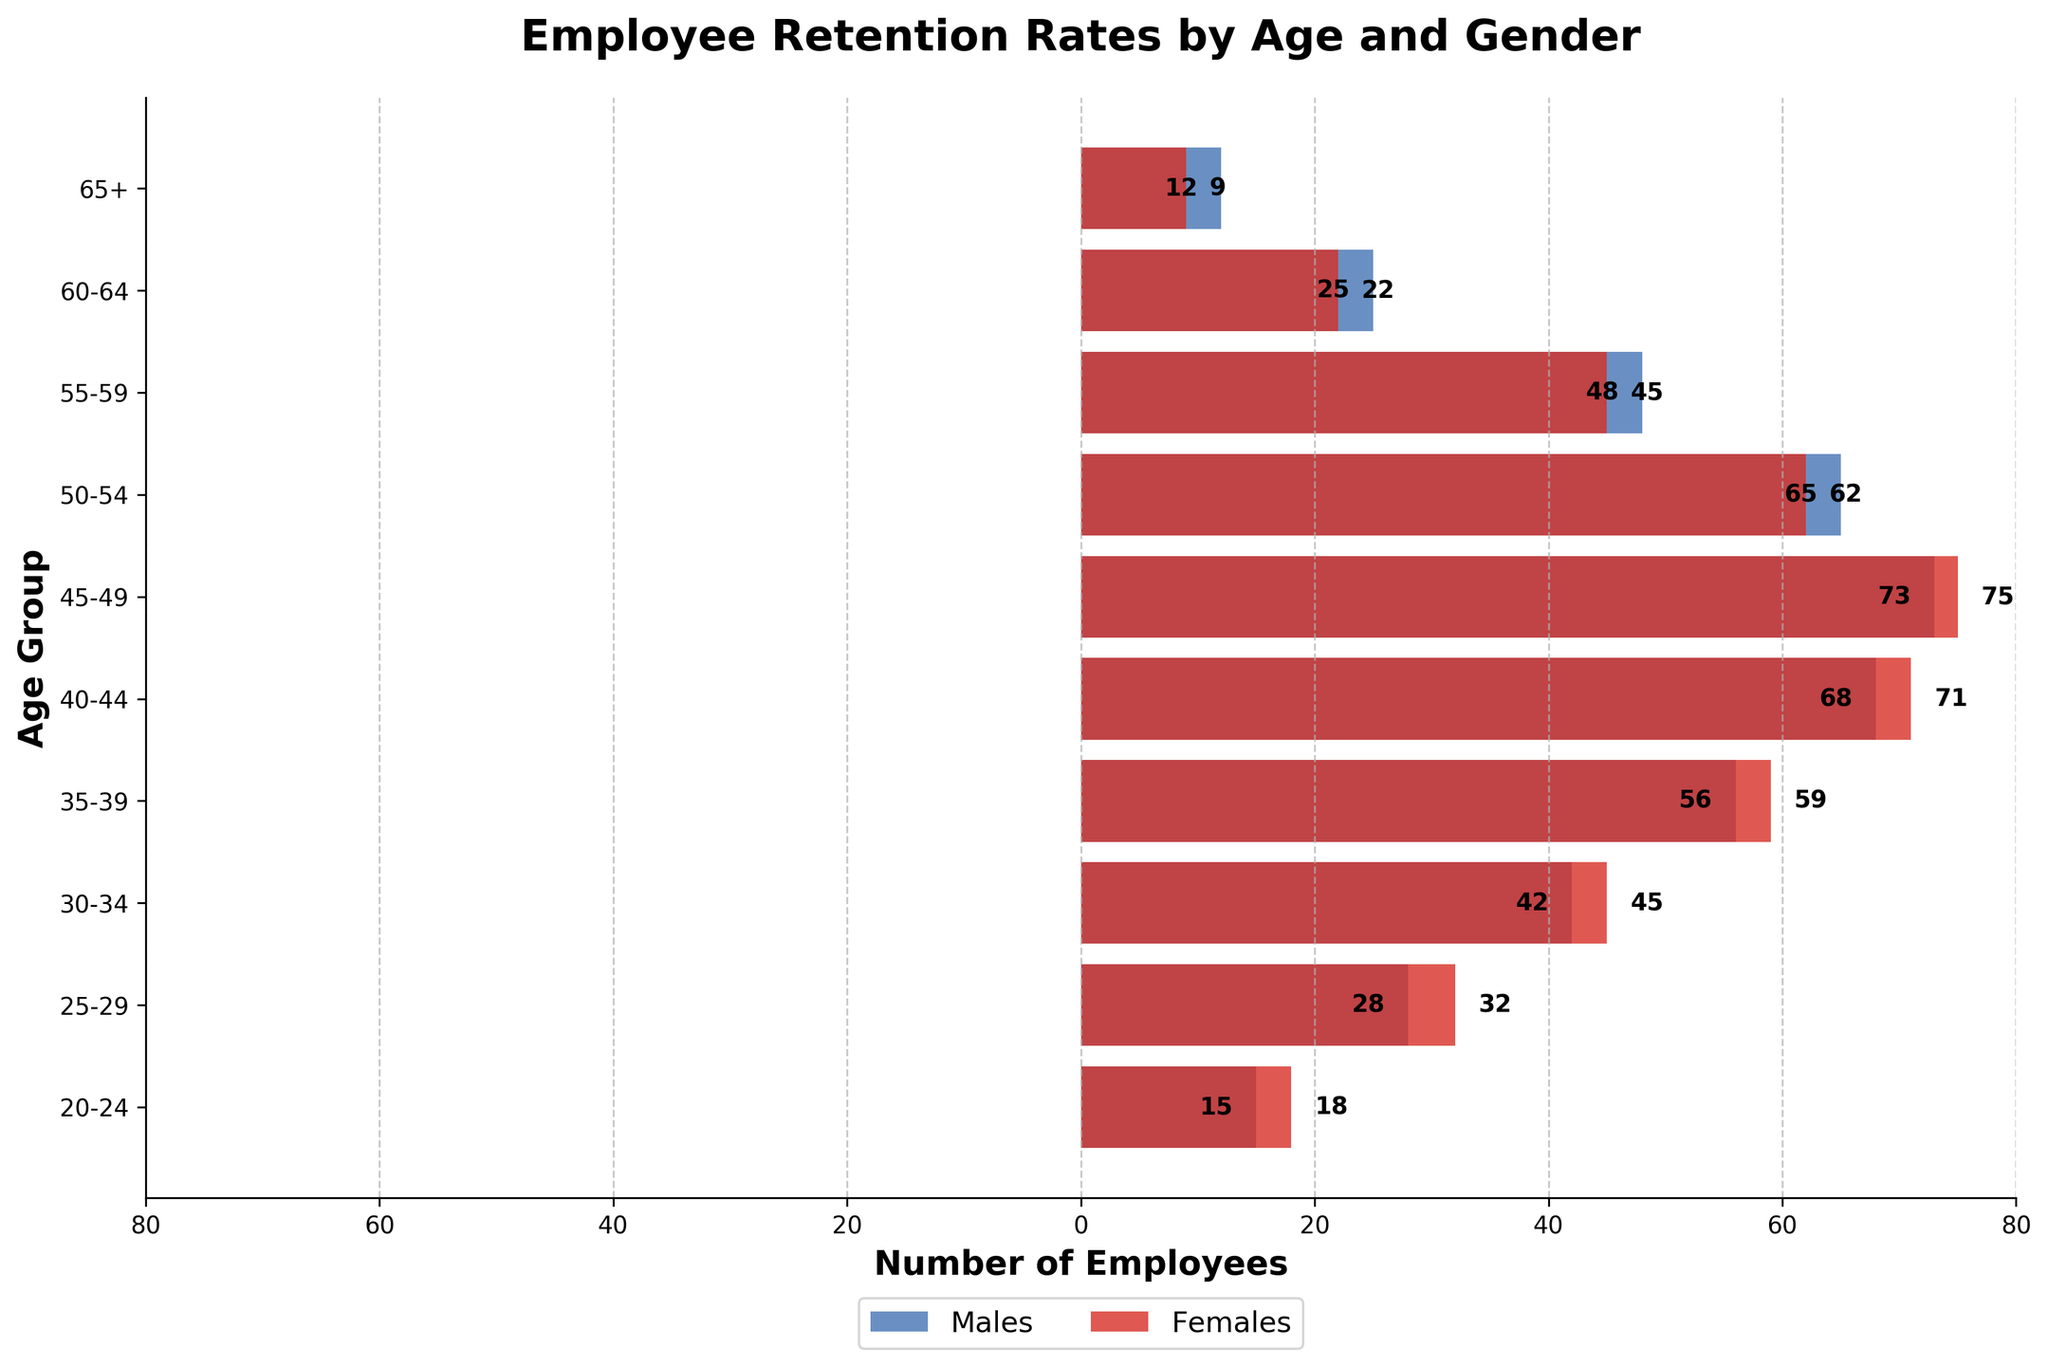What is the title of the figure? Look at the top of the figure; the title is usually prominently displayed.
Answer: Employee Retention Rates by Age and Gender What is the age group with the largest number of male employees? Identify the bar representing males that extends the furthest to the left.
Answer: 45-49 How many female employees are in the 30-34 age group? Find the bar corresponding to the 30-34 age group and read the value associated with the female section (right side).
Answer: 45 Which age group has more female employees than male employees? Compare the lengths of the bars for males and females in each age group to identify where the females' bar is longer.
Answer: All age groups What is the total number of male employees in the age groups 25-29 and 30-34? Sum the male employees in the 25-29 and 30-34 age groups: 28 + 42.
Answer: 70 Which age group has the smallest difference in the number of male and female employees? Calculate the difference between the male and female employees for each age group and find the smallest.
Answer: 20-24 What is the ratio of female to male employees in the 40-44 age group? Divide the number of female employees by the number of male employees in the 40-44 age group: 71/68.
Answer: ~1.04 How does the number of employees aged 55-59 compare between males and females? Identify the bars for the 55-59 age group and compare their lengths.
Answer: Males have more than females What is the total number of employees in the 65+ age group? Sum the number of male and female employees in the 65+ age group: 12 + 9.
Answer: 21 